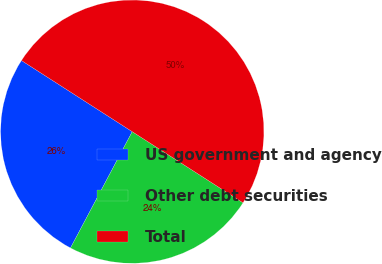Convert chart to OTSL. <chart><loc_0><loc_0><loc_500><loc_500><pie_chart><fcel>US government and agency<fcel>Other debt securities<fcel>Total<nl><fcel>26.32%<fcel>23.68%<fcel>50.0%<nl></chart> 